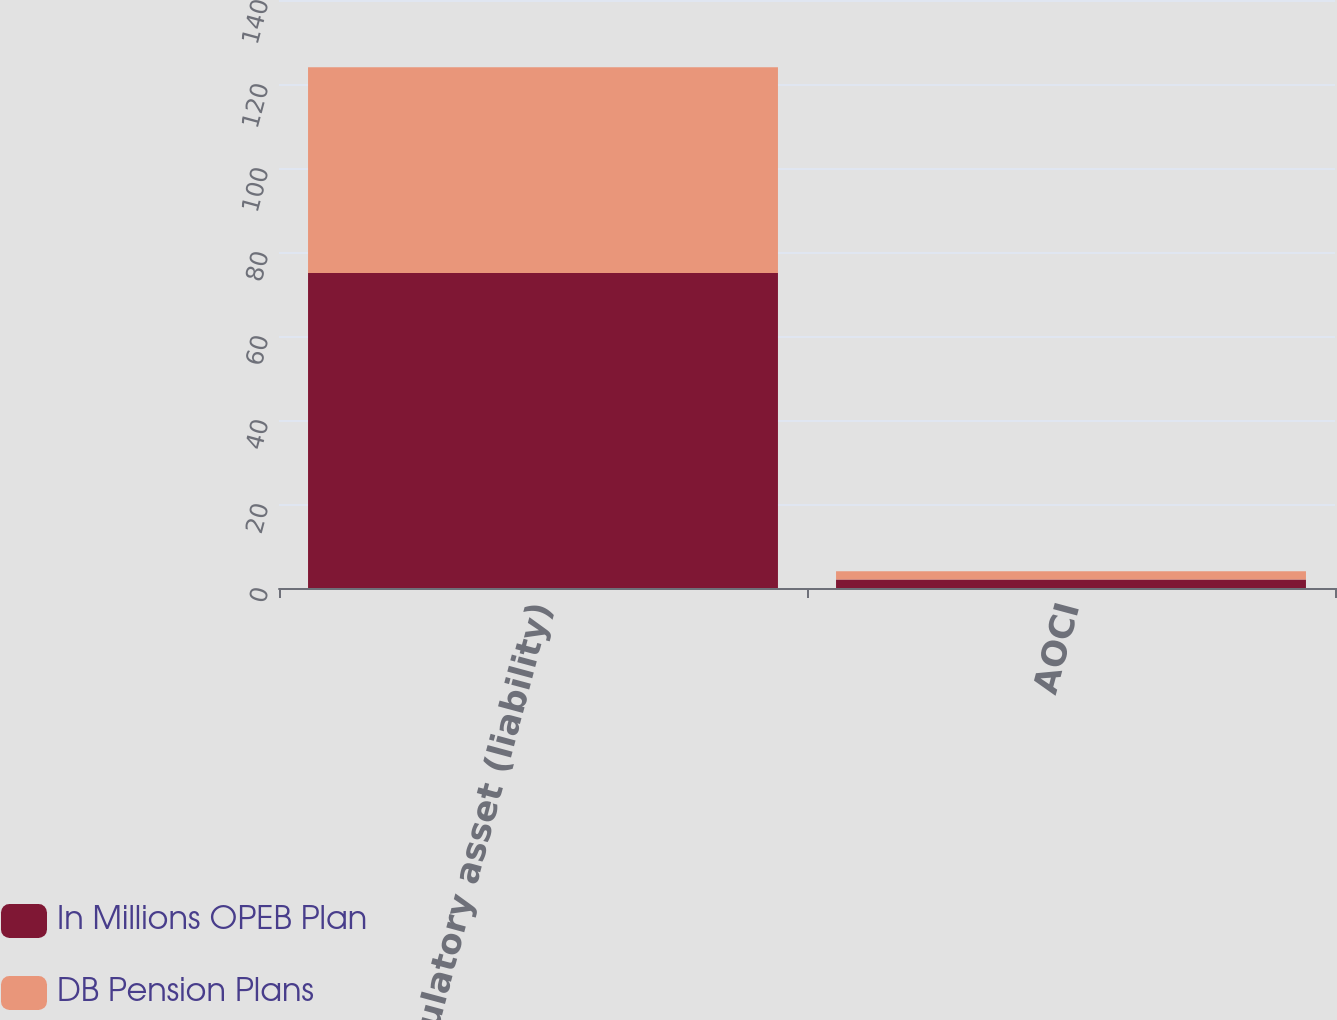Convert chart. <chart><loc_0><loc_0><loc_500><loc_500><stacked_bar_chart><ecel><fcel>Regulatory asset (liability)<fcel>AOCI<nl><fcel>In Millions OPEB Plan<fcel>75<fcel>2<nl><fcel>DB Pension Plans<fcel>49<fcel>2<nl></chart> 